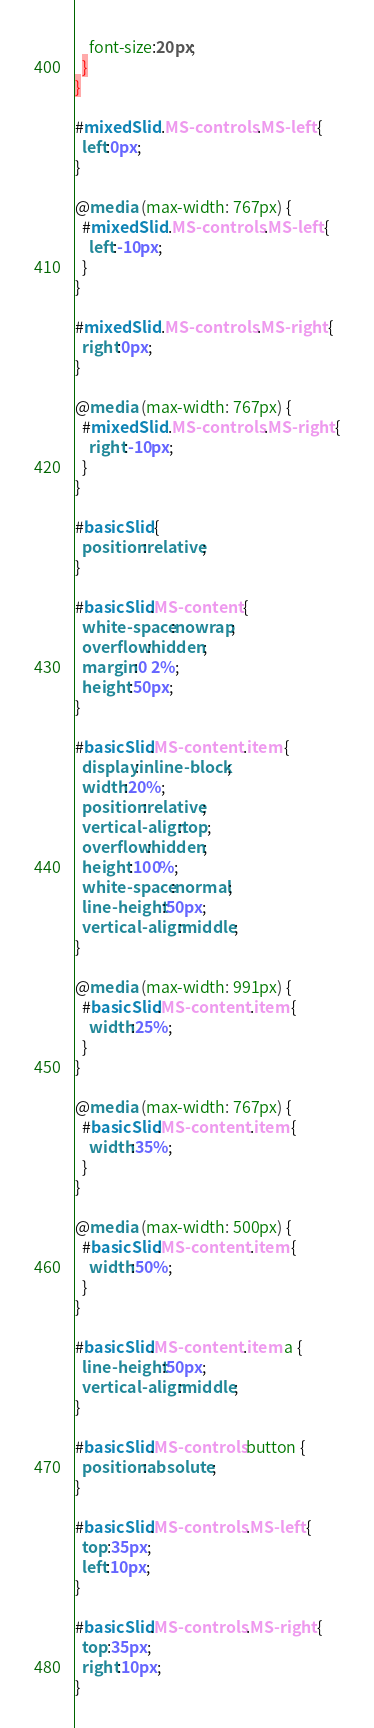Convert code to text. <code><loc_0><loc_0><loc_500><loc_500><_CSS_>    font-size:20px;
  }
}

#mixedSlid .MS-controls .MS-left {
  left:0px;
}

@media (max-width: 767px) {
  #mixedSlid .MS-controls .MS-left {
    left:-10px;
  }
}

#mixedSlid .MS-controls .MS-right {
  right:0px;
}

@media (max-width: 767px) {
  #mixedSlid .MS-controls .MS-right {
    right:-10px;
  }
}

#basicSlid {
  position:relative;
}

#basicSlid.MS-content {
  white-space:nowrap;
  overflow:hidden;
  margin:0 2%;
  height:50px;
}

#basicSlid.MS-content .item {
  display:inline-block;
  width:20%;
  position:relative;
  vertical-align:top;
  overflow:hidden;
  height:100%;
  white-space:normal;
  line-height:50px;
  vertical-align:middle;
}

@media (max-width: 991px) {
  #basicSlid.MS-content .item {
    width:25%;
  }
}

@media (max-width: 767px) {
  #basicSlid.MS-content .item {
    width:35%;
  }
}

@media (max-width: 500px) {
  #basicSlid.MS-content .item {
    width:50%;
  }
}

#basicSlid.MS-content .item a {
  line-height:50px;
  vertical-align:middle;
}

#basicSlid.MS-controls button {
  position:absolute;
}

#basicSlid.MS-controls .MS-left {
  top:35px;
  left:10px;
}

#basicSlid.MS-controls .MS-right {
  top:35px;
  right:10px;
}

</code> 